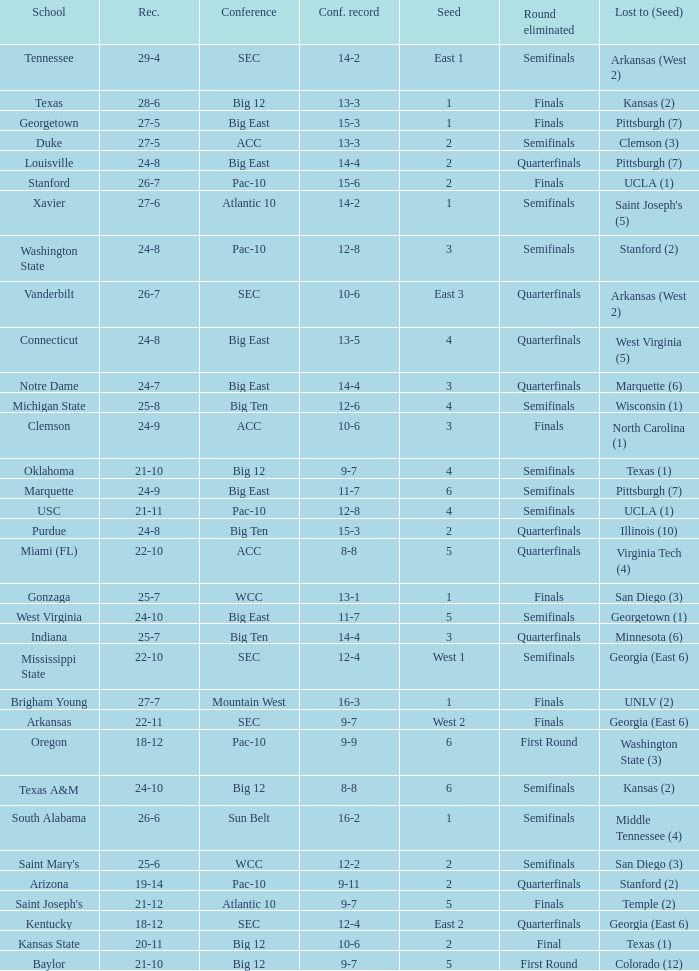Name the conference record where seed is 3 and record is 24-9 10-6. 